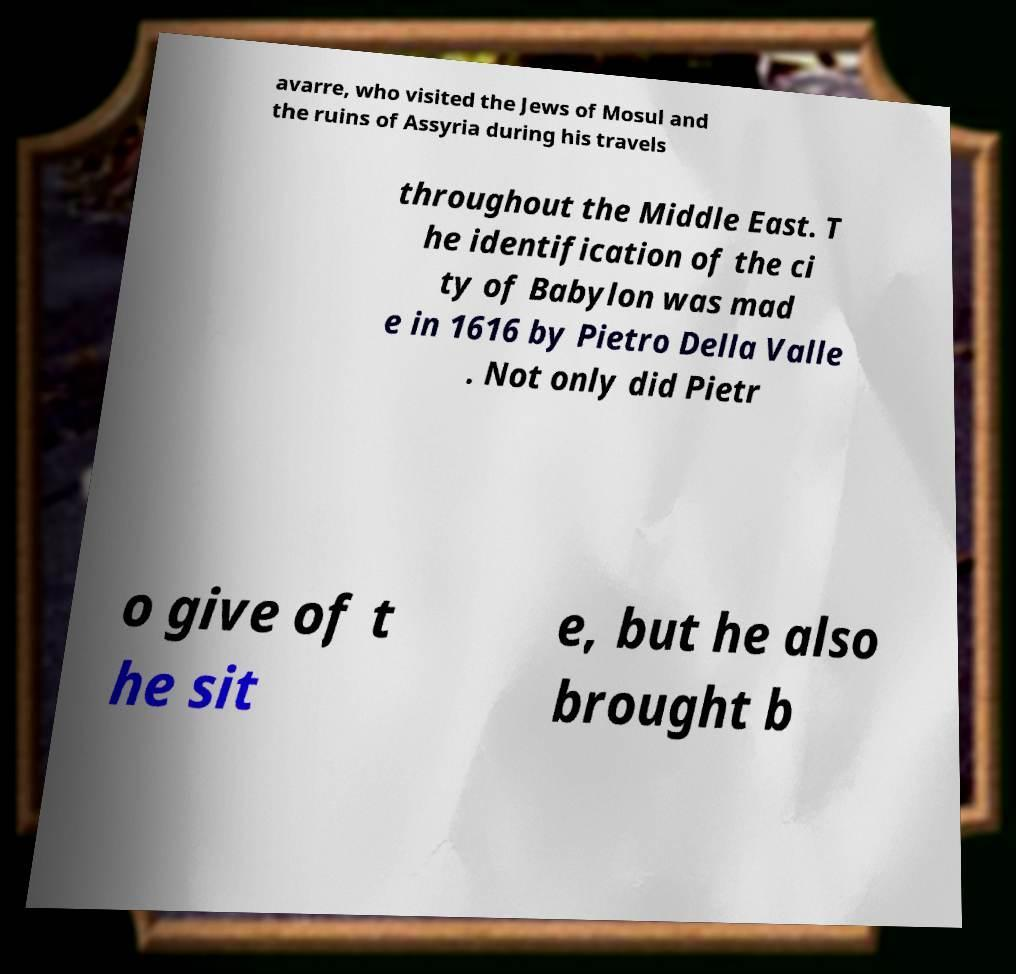Please identify and transcribe the text found in this image. avarre, who visited the Jews of Mosul and the ruins of Assyria during his travels throughout the Middle East. T he identification of the ci ty of Babylon was mad e in 1616 by Pietro Della Valle . Not only did Pietr o give of t he sit e, but he also brought b 